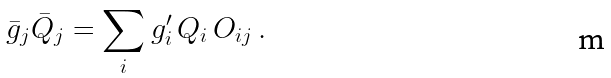<formula> <loc_0><loc_0><loc_500><loc_500>\bar { g } _ { j } \bar { Q } _ { j } = \sum _ { i } g ^ { \prime } _ { i } \, Q _ { i } \, O _ { i j } \, .</formula> 